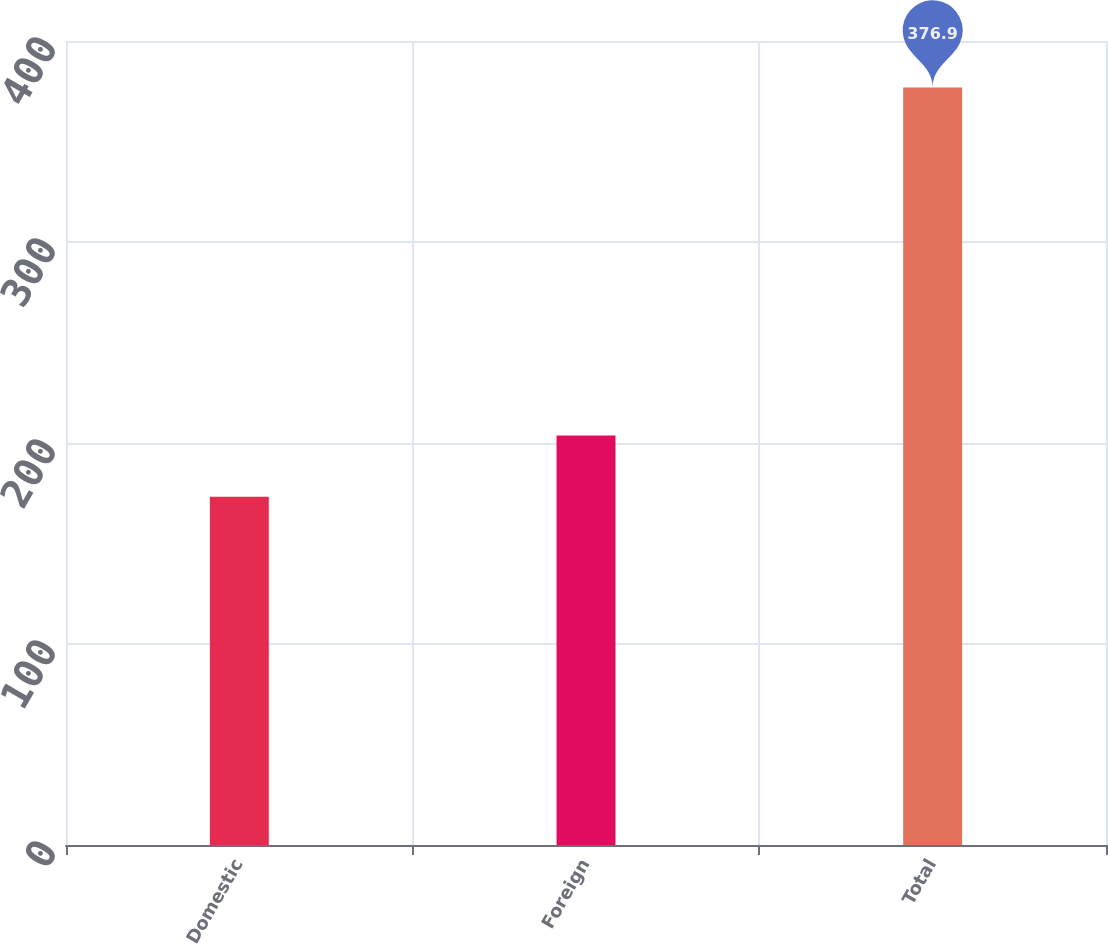Convert chart. <chart><loc_0><loc_0><loc_500><loc_500><bar_chart><fcel>Domestic<fcel>Foreign<fcel>Total<nl><fcel>173.2<fcel>203.7<fcel>376.9<nl></chart> 